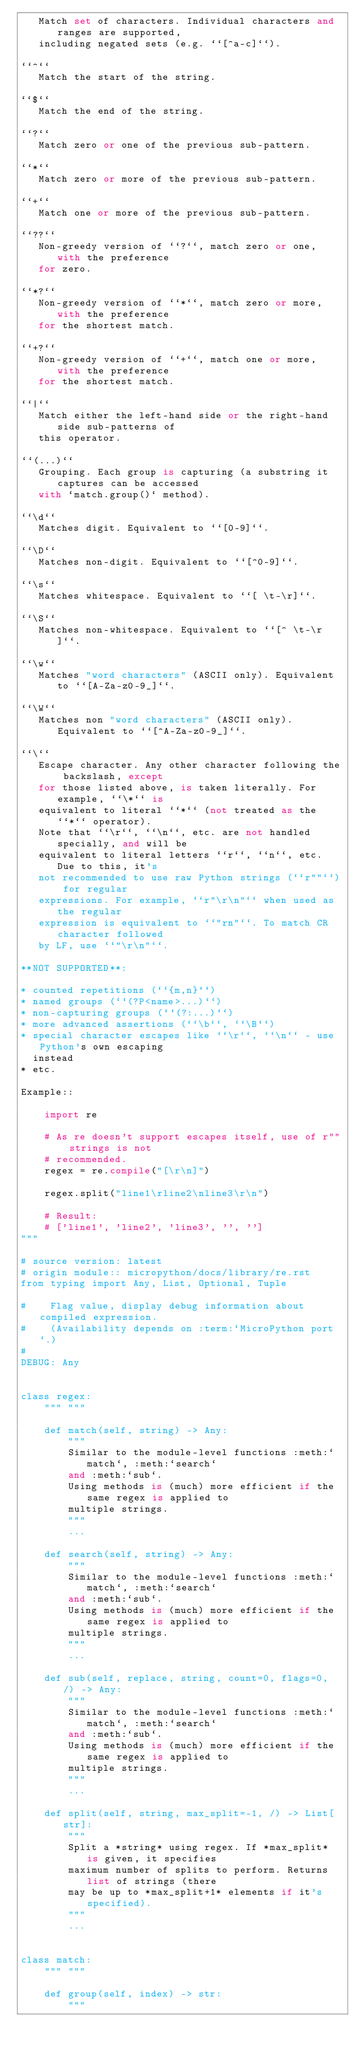Convert code to text. <code><loc_0><loc_0><loc_500><loc_500><_Python_>   Match set of characters. Individual characters and ranges are supported,
   including negated sets (e.g. ``[^a-c]``).

``^``
   Match the start of the string.

``$``
   Match the end of the string.

``?``
   Match zero or one of the previous sub-pattern.

``*``
   Match zero or more of the previous sub-pattern.

``+``
   Match one or more of the previous sub-pattern.

``??``
   Non-greedy version of ``?``, match zero or one, with the preference
   for zero.

``*?``
   Non-greedy version of ``*``, match zero or more, with the preference
   for the shortest match.

``+?``
   Non-greedy version of ``+``, match one or more, with the preference
   for the shortest match.

``|``
   Match either the left-hand side or the right-hand side sub-patterns of
   this operator.

``(...)``
   Grouping. Each group is capturing (a substring it captures can be accessed
   with `match.group()` method).

``\d``
   Matches digit. Equivalent to ``[0-9]``.

``\D``
   Matches non-digit. Equivalent to ``[^0-9]``.

``\s``
   Matches whitespace. Equivalent to ``[ \t-\r]``.

``\S``
   Matches non-whitespace. Equivalent to ``[^ \t-\r]``.

``\w``
   Matches "word characters" (ASCII only). Equivalent to ``[A-Za-z0-9_]``.

``\W``
   Matches non "word characters" (ASCII only). Equivalent to ``[^A-Za-z0-9_]``.

``\``
   Escape character. Any other character following the backslash, except
   for those listed above, is taken literally. For example, ``\*`` is
   equivalent to literal ``*`` (not treated as the ``*`` operator).
   Note that ``\r``, ``\n``, etc. are not handled specially, and will be
   equivalent to literal letters ``r``, ``n``, etc. Due to this, it's
   not recommended to use raw Python strings (``r""``) for regular
   expressions. For example, ``r"\r\n"`` when used as the regular
   expression is equivalent to ``"rn"``. To match CR character followed
   by LF, use ``"\r\n"``.

**NOT SUPPORTED**:

* counted repetitions (``{m,n}``)
* named groups (``(?P<name>...)``)
* non-capturing groups (``(?:...)``)
* more advanced assertions (``\b``, ``\B``)
* special character escapes like ``\r``, ``\n`` - use Python's own escaping
  instead
* etc.

Example::

    import re

    # As re doesn't support escapes itself, use of r"" strings is not
    # recommended.
    regex = re.compile("[\r\n]")

    regex.split("line1\rline2\nline3\r\n")

    # Result:
    # ['line1', 'line2', 'line3', '', '']
"""

# source version: latest
# origin module:: micropython/docs/library/re.rst
from typing import Any, List, Optional, Tuple

#    Flag value, display debug information about compiled expression.
#    (Availability depends on :term:`MicroPython port`.)
#
DEBUG: Any


class regex:
    """ """

    def match(self, string) -> Any:
        """
        Similar to the module-level functions :meth:`match`, :meth:`search`
        and :meth:`sub`.
        Using methods is (much) more efficient if the same regex is applied to
        multiple strings.
        """
        ...

    def search(self, string) -> Any:
        """
        Similar to the module-level functions :meth:`match`, :meth:`search`
        and :meth:`sub`.
        Using methods is (much) more efficient if the same regex is applied to
        multiple strings.
        """
        ...

    def sub(self, replace, string, count=0, flags=0, /) -> Any:
        """
        Similar to the module-level functions :meth:`match`, :meth:`search`
        and :meth:`sub`.
        Using methods is (much) more efficient if the same regex is applied to
        multiple strings.
        """
        ...

    def split(self, string, max_split=-1, /) -> List[str]:
        """
        Split a *string* using regex. If *max_split* is given, it specifies
        maximum number of splits to perform. Returns list of strings (there
        may be up to *max_split+1* elements if it's specified).
        """
        ...


class match:
    """ """

    def group(self, index) -> str:
        """</code> 